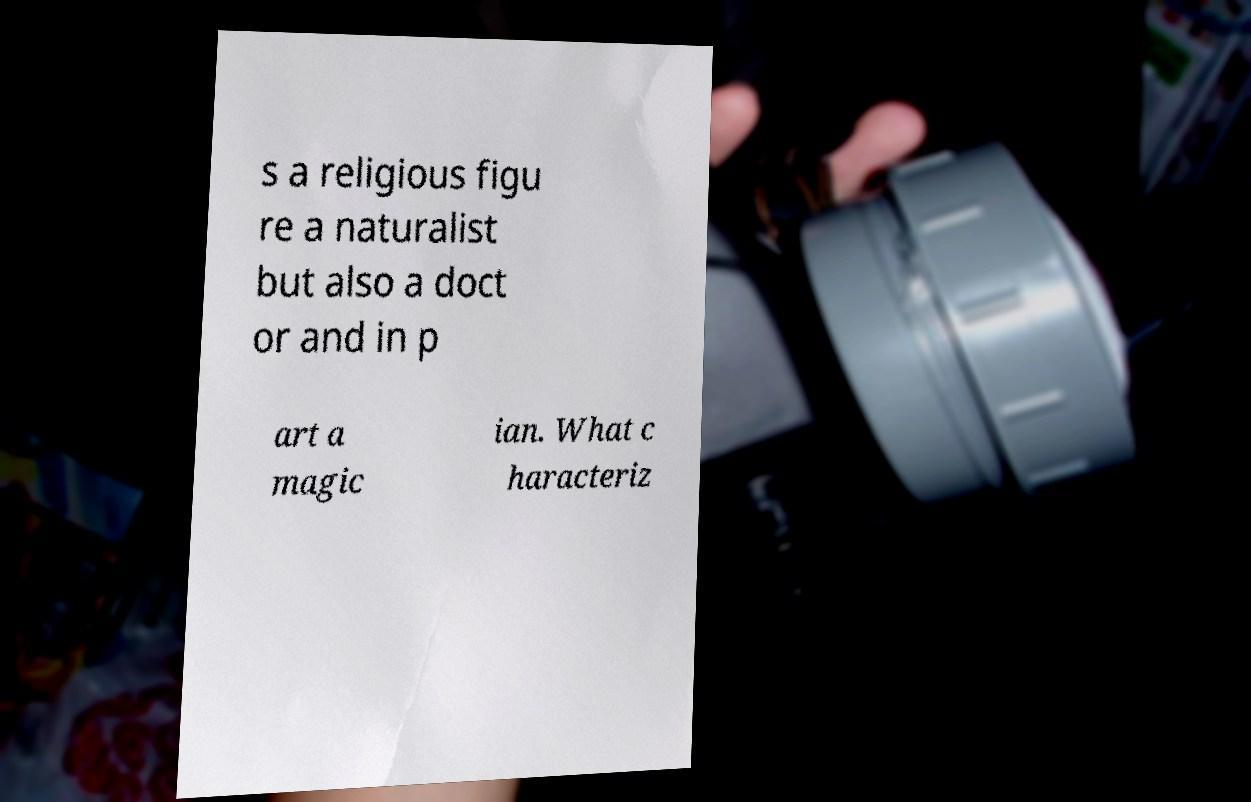I need the written content from this picture converted into text. Can you do that? s a religious figu re a naturalist but also a doct or and in p art a magic ian. What c haracteriz 